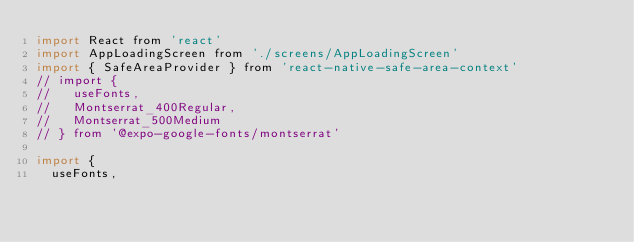<code> <loc_0><loc_0><loc_500><loc_500><_JavaScript_>import React from 'react'
import AppLoadingScreen from './screens/AppLoadingScreen'
import { SafeAreaProvider } from 'react-native-safe-area-context'
// import {
//   useFonts,
//   Montserrat_400Regular,
//   Montserrat_500Medium
// } from '@expo-google-fonts/montserrat'

import {
  useFonts,</code> 